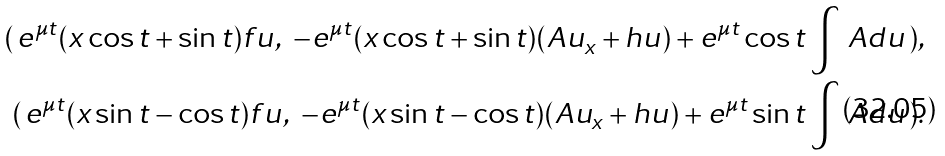Convert formula to latex. <formula><loc_0><loc_0><loc_500><loc_500>( \, e ^ { \mu t } ( x \cos t + \sin t ) f u , \ - e ^ { \mu t } ( x \cos t + \sin t ) ( A u _ { x } + h u ) + e ^ { \mu t } \cos t \int \, A d u \, ) , \\ ( \, e ^ { \mu t } ( x \sin t - \cos t ) f u , \ - e ^ { \mu t } ( x \sin t - \cos t ) ( A u _ { x } + h u ) + e ^ { \mu t } \sin t \int \, A d u \, ) .</formula> 